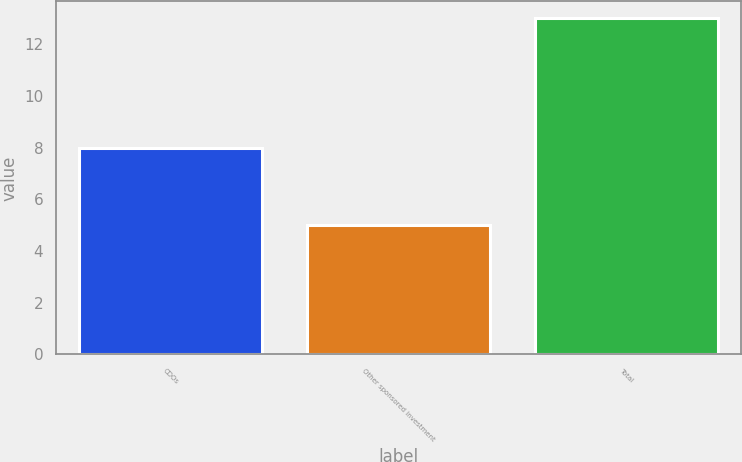Convert chart to OTSL. <chart><loc_0><loc_0><loc_500><loc_500><bar_chart><fcel>CDOs<fcel>Other sponsored investment<fcel>Total<nl><fcel>8<fcel>5<fcel>13<nl></chart> 